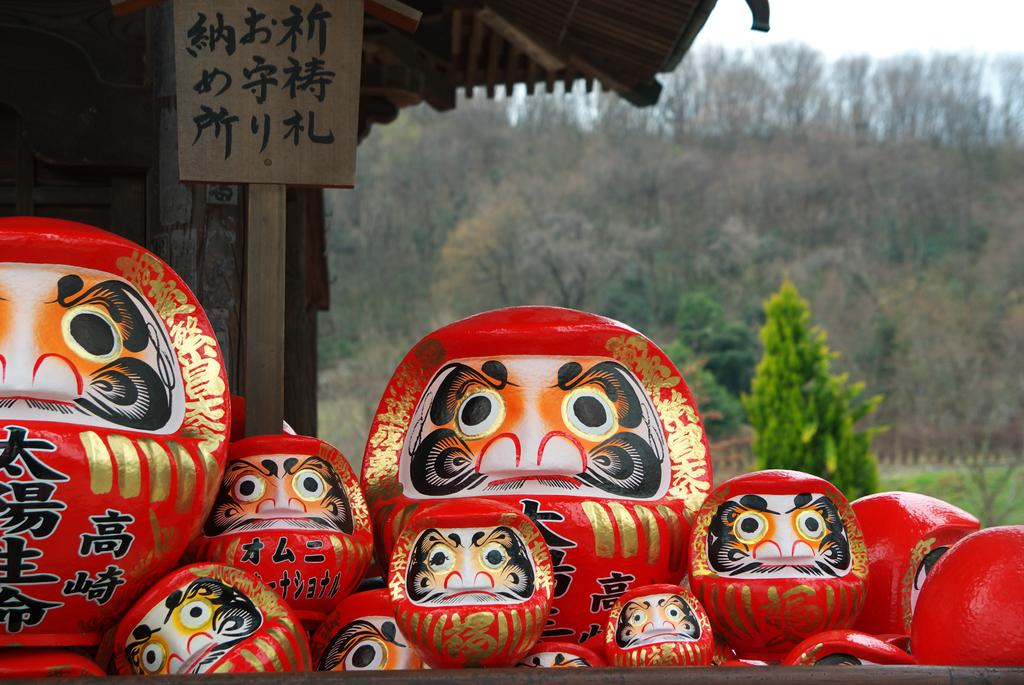What type of objects have paintings in the image? There are objects with paintings on them in the image. What material is the board in the image made of? The board in the image is made of wood. What structure can be seen in the image? There is a house in the image. What type of vegetation is visible in the background of the image? There are trees in the background of the image. What part of the natural environment is visible in the background of the image? The sky is visible in the background of the image. Can you tell me how many letters are on the dock in the image? There is no dock present in the image, and therefore no letters can be found on it. What type of floor is visible in the image? There is no specific mention of a floor in the image; the focus is on the objects with paintings, the wooden board, the house, and the background vegetation and sky. 